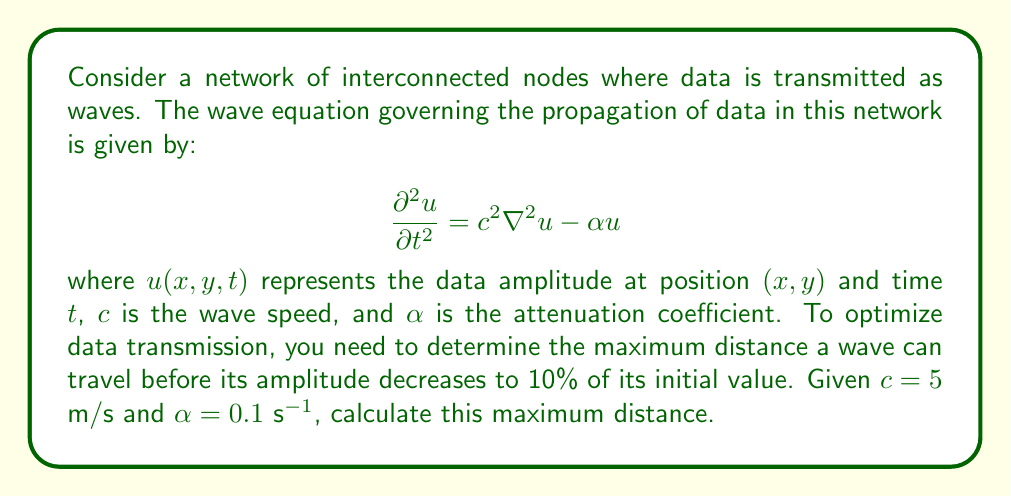Can you answer this question? To solve this problem, we need to consider the following steps:

1) The wave equation given describes the propagation of data in the network. The term $c^2 \nabla^2 u$ represents the wave propagation, while $-\alpha u$ represents the attenuation.

2) For a wave traveling in one direction (say, x-direction), we can assume a solution of the form:

   $$u(x,t) = A e^{i(kx-\omega t)} e^{-\beta x}$$

   where $A$ is the initial amplitude, $k$ is the wave number, $\omega$ is the angular frequency, and $\beta$ is the spatial attenuation coefficient.

3) Substituting this into the wave equation:

   $$(-\omega^2 + 2ik\beta\omega + \beta^2)A = (c^2k^2 - 2ic^2k\beta - c^2\beta^2 - \alpha)A$$

4) Equating real and imaginary parts:

   Real: $-\omega^2 + \beta^2 = c^2k^2 - c^2\beta^2 - \alpha$
   Imaginary: $2k\beta\omega = -2c^2k\beta$

5) From the imaginary part: $\omega = -c^2$

6) Substituting this into the real part:

   $$c^4 + \beta^2 = c^2k^2 - c^2\beta^2 - \alpha$$
   $$c^2k^2 = c^4 + c^2\beta^2 + \beta^2 + \alpha$$
   $$k^2 = c^2 + \beta^2 + \frac{\beta^2 + \alpha}{c^2}$$

7) The spatial attenuation coefficient $\beta$ determines how quickly the wave amplitude decreases with distance. We want the amplitude to decrease to 10% of its initial value, which means:

   $$e^{-\beta x} = 0.1$$
   $$-\beta x = \ln(0.1)$$
   $$x = -\frac{\ln(0.1)}{\beta}$$

8) To find $\beta$, we can use the dispersion relation from step 6. For a non-oscillatory decay, we need $k=0$:

   $$0 = c^2 + \beta^2 + \frac{\beta^2 + \alpha}{c^2}$$
   $$\beta^4 + (2c^2 + \alpha)\beta^2 + \alpha c^2 = 0$$

9) This is a quadratic equation in $\beta^2$. Solving it:

   $$\beta^2 = \frac{-(2c^2 + \alpha) + \sqrt{(2c^2 + \alpha)^2 - 4\alpha c^2}}{2}$$

10) Substituting the given values $c = 5$ m/s and $\alpha = 0.1$ s$^{-1}$:

    $$\beta^2 = \frac{-(2(5^2) + 0.1) + \sqrt{(2(5^2) + 0.1)^2 - 4(0.1)(5^2)}}{2} \approx 0.002$$

    $$\beta \approx 0.0447 \text{ m}^{-1}$$

11) Finally, we can calculate the maximum distance:

    $$x = -\frac{\ln(0.1)}{0.0447} \approx 51.5 \text{ m}$$

Therefore, the maximum distance the wave can travel before its amplitude decreases to 10% of its initial value is approximately 51.5 meters.
Answer: The maximum distance the wave can travel before its amplitude decreases to 10% of its initial value is approximately 51.5 meters. 